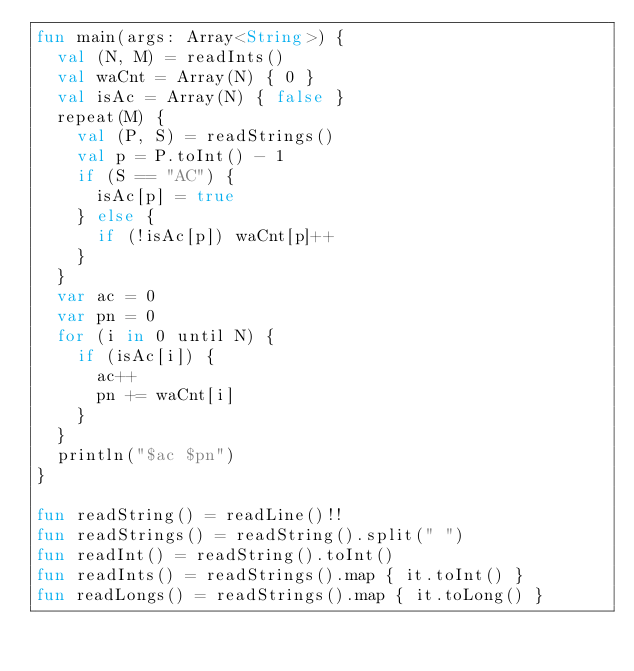<code> <loc_0><loc_0><loc_500><loc_500><_Kotlin_>fun main(args: Array<String>) {
  val (N, M) = readInts()
  val waCnt = Array(N) { 0 }
  val isAc = Array(N) { false }
  repeat(M) {
    val (P, S) = readStrings()
    val p = P.toInt() - 1
    if (S == "AC") {
      isAc[p] = true
    } else {
      if (!isAc[p]) waCnt[p]++
    }
  }
  var ac = 0
  var pn = 0
  for (i in 0 until N) {
    if (isAc[i]) {
      ac++
      pn += waCnt[i]
    }
  }
  println("$ac $pn")
}

fun readString() = readLine()!!
fun readStrings() = readString().split(" ")
fun readInt() = readString().toInt()
fun readInts() = readStrings().map { it.toInt() }
fun readLongs() = readStrings().map { it.toLong() }
</code> 